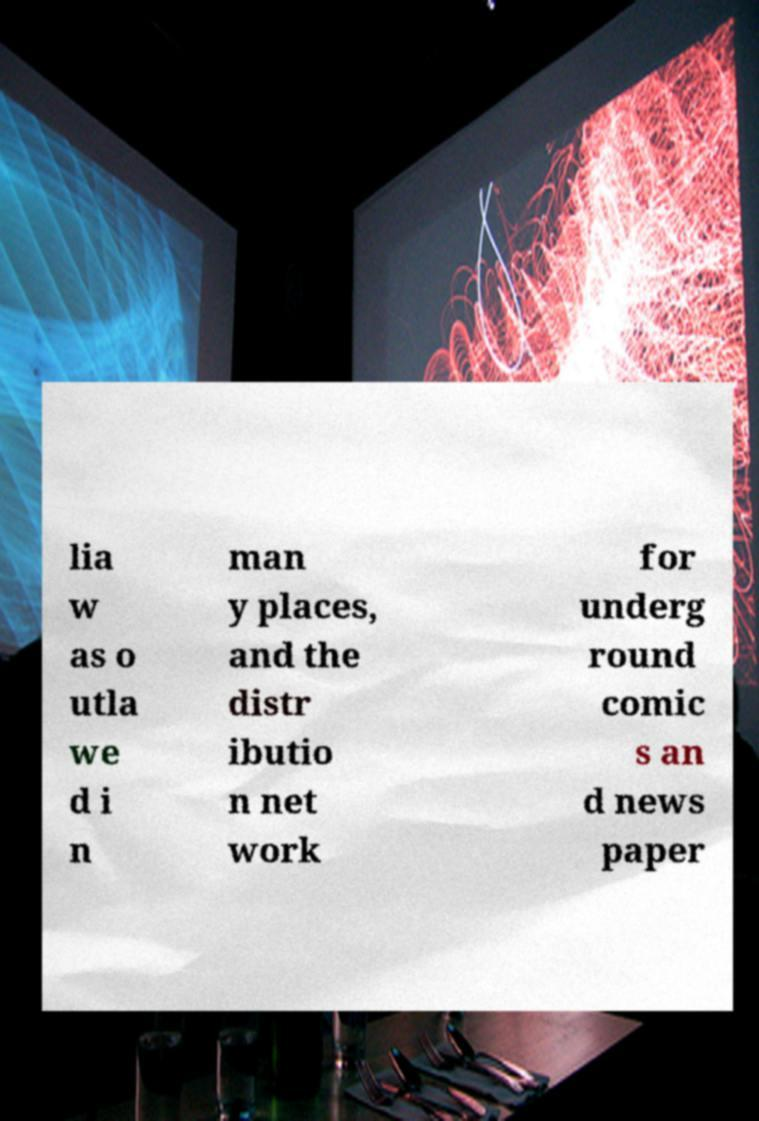Can you accurately transcribe the text from the provided image for me? lia w as o utla we d i n man y places, and the distr ibutio n net work for underg round comic s an d news paper 